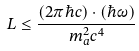<formula> <loc_0><loc_0><loc_500><loc_500>L \leq \frac { ( 2 \pi \hbar { c } ) \cdot ( \hbar { \omega } ) } { m _ { a } ^ { 2 } c ^ { 4 } }</formula> 